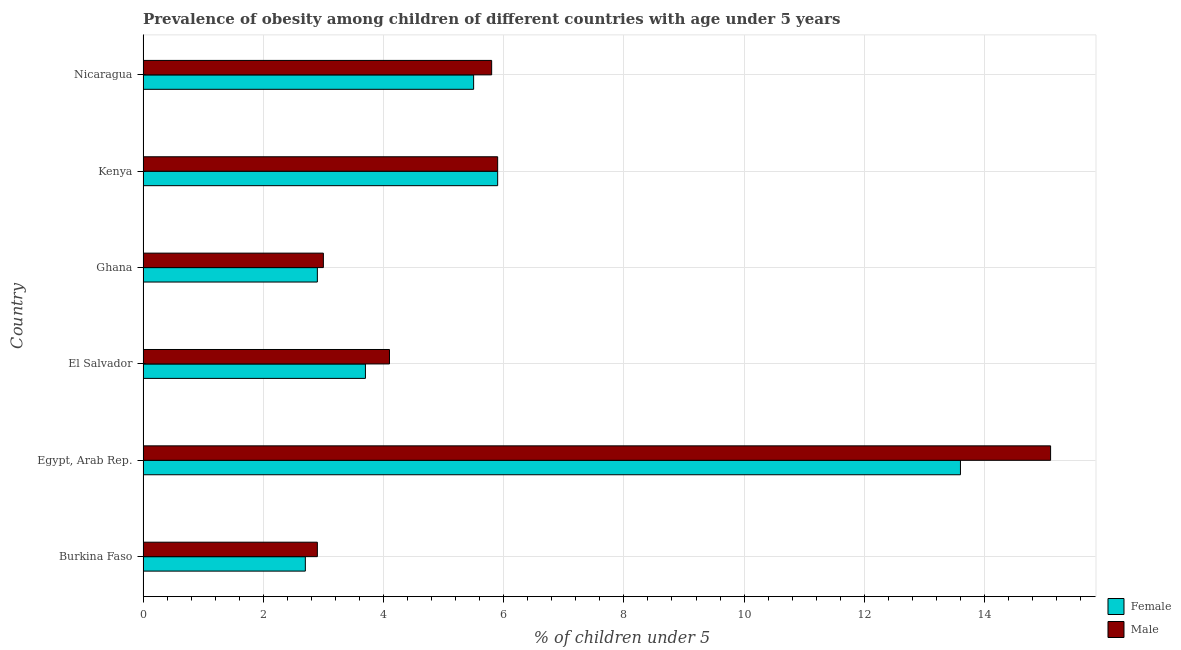How many groups of bars are there?
Your answer should be very brief. 6. Are the number of bars per tick equal to the number of legend labels?
Provide a short and direct response. Yes. Are the number of bars on each tick of the Y-axis equal?
Ensure brevity in your answer.  Yes. What is the label of the 2nd group of bars from the top?
Provide a succinct answer. Kenya. What is the percentage of obese male children in Kenya?
Offer a very short reply. 5.9. Across all countries, what is the maximum percentage of obese female children?
Give a very brief answer. 13.6. Across all countries, what is the minimum percentage of obese female children?
Give a very brief answer. 2.7. In which country was the percentage of obese female children maximum?
Provide a short and direct response. Egypt, Arab Rep. In which country was the percentage of obese male children minimum?
Offer a very short reply. Burkina Faso. What is the total percentage of obese male children in the graph?
Your response must be concise. 36.8. What is the difference between the percentage of obese male children in Burkina Faso and that in Egypt, Arab Rep.?
Your answer should be compact. -12.2. What is the difference between the percentage of obese male children in Burkina Faso and the percentage of obese female children in El Salvador?
Your response must be concise. -0.8. What is the average percentage of obese female children per country?
Offer a terse response. 5.72. In how many countries, is the percentage of obese male children greater than 1.2000000000000002 %?
Offer a terse response. 6. What is the ratio of the percentage of obese male children in El Salvador to that in Ghana?
Your response must be concise. 1.37. Is the difference between the percentage of obese female children in Egypt, Arab Rep. and Ghana greater than the difference between the percentage of obese male children in Egypt, Arab Rep. and Ghana?
Your answer should be compact. No. In how many countries, is the percentage of obese male children greater than the average percentage of obese male children taken over all countries?
Your answer should be compact. 1. Is the sum of the percentage of obese male children in Egypt, Arab Rep. and Nicaragua greater than the maximum percentage of obese female children across all countries?
Your response must be concise. Yes. How many bars are there?
Your response must be concise. 12. Are the values on the major ticks of X-axis written in scientific E-notation?
Your answer should be compact. No. Does the graph contain any zero values?
Make the answer very short. No. Does the graph contain grids?
Ensure brevity in your answer.  Yes. How many legend labels are there?
Make the answer very short. 2. What is the title of the graph?
Make the answer very short. Prevalence of obesity among children of different countries with age under 5 years. Does "Residents" appear as one of the legend labels in the graph?
Keep it short and to the point. No. What is the label or title of the X-axis?
Ensure brevity in your answer.   % of children under 5. What is the  % of children under 5 of Female in Burkina Faso?
Offer a very short reply. 2.7. What is the  % of children under 5 of Male in Burkina Faso?
Provide a succinct answer. 2.9. What is the  % of children under 5 of Female in Egypt, Arab Rep.?
Offer a very short reply. 13.6. What is the  % of children under 5 of Male in Egypt, Arab Rep.?
Provide a succinct answer. 15.1. What is the  % of children under 5 of Female in El Salvador?
Your answer should be very brief. 3.7. What is the  % of children under 5 in Male in El Salvador?
Your answer should be very brief. 4.1. What is the  % of children under 5 of Female in Ghana?
Your answer should be very brief. 2.9. What is the  % of children under 5 of Female in Kenya?
Make the answer very short. 5.9. What is the  % of children under 5 of Male in Kenya?
Provide a succinct answer. 5.9. What is the  % of children under 5 of Male in Nicaragua?
Offer a very short reply. 5.8. Across all countries, what is the maximum  % of children under 5 in Female?
Keep it short and to the point. 13.6. Across all countries, what is the maximum  % of children under 5 in Male?
Make the answer very short. 15.1. Across all countries, what is the minimum  % of children under 5 in Female?
Keep it short and to the point. 2.7. Across all countries, what is the minimum  % of children under 5 in Male?
Provide a succinct answer. 2.9. What is the total  % of children under 5 of Female in the graph?
Provide a succinct answer. 34.3. What is the total  % of children under 5 of Male in the graph?
Give a very brief answer. 36.8. What is the difference between the  % of children under 5 of Female in Burkina Faso and that in Egypt, Arab Rep.?
Offer a terse response. -10.9. What is the difference between the  % of children under 5 of Male in Burkina Faso and that in Egypt, Arab Rep.?
Ensure brevity in your answer.  -12.2. What is the difference between the  % of children under 5 of Male in Burkina Faso and that in Ghana?
Keep it short and to the point. -0.1. What is the difference between the  % of children under 5 in Female in Burkina Faso and that in Nicaragua?
Make the answer very short. -2.8. What is the difference between the  % of children under 5 of Male in Egypt, Arab Rep. and that in El Salvador?
Your response must be concise. 11. What is the difference between the  % of children under 5 in Female in Egypt, Arab Rep. and that in Ghana?
Keep it short and to the point. 10.7. What is the difference between the  % of children under 5 in Male in Egypt, Arab Rep. and that in Ghana?
Your response must be concise. 12.1. What is the difference between the  % of children under 5 in Female in Egypt, Arab Rep. and that in Kenya?
Ensure brevity in your answer.  7.7. What is the difference between the  % of children under 5 of Male in Egypt, Arab Rep. and that in Kenya?
Ensure brevity in your answer.  9.2. What is the difference between the  % of children under 5 in Female in El Salvador and that in Ghana?
Your response must be concise. 0.8. What is the difference between the  % of children under 5 of Male in El Salvador and that in Ghana?
Give a very brief answer. 1.1. What is the difference between the  % of children under 5 of Female in El Salvador and that in Kenya?
Your response must be concise. -2.2. What is the difference between the  % of children under 5 of Male in El Salvador and that in Kenya?
Keep it short and to the point. -1.8. What is the difference between the  % of children under 5 of Male in El Salvador and that in Nicaragua?
Your response must be concise. -1.7. What is the difference between the  % of children under 5 in Male in Ghana and that in Nicaragua?
Offer a terse response. -2.8. What is the difference between the  % of children under 5 of Female in Kenya and that in Nicaragua?
Ensure brevity in your answer.  0.4. What is the difference between the  % of children under 5 in Male in Kenya and that in Nicaragua?
Offer a very short reply. 0.1. What is the difference between the  % of children under 5 in Female in Burkina Faso and the  % of children under 5 in Male in El Salvador?
Your response must be concise. -1.4. What is the difference between the  % of children under 5 in Female in Egypt, Arab Rep. and the  % of children under 5 in Male in Kenya?
Your answer should be compact. 7.7. What is the difference between the  % of children under 5 in Female in Kenya and the  % of children under 5 in Male in Nicaragua?
Ensure brevity in your answer.  0.1. What is the average  % of children under 5 in Female per country?
Your answer should be compact. 5.72. What is the average  % of children under 5 of Male per country?
Offer a very short reply. 6.13. What is the difference between the  % of children under 5 in Female and  % of children under 5 in Male in Burkina Faso?
Make the answer very short. -0.2. What is the difference between the  % of children under 5 in Female and  % of children under 5 in Male in Egypt, Arab Rep.?
Offer a terse response. -1.5. What is the difference between the  % of children under 5 in Female and  % of children under 5 in Male in El Salvador?
Offer a very short reply. -0.4. What is the difference between the  % of children under 5 in Female and  % of children under 5 in Male in Ghana?
Keep it short and to the point. -0.1. What is the difference between the  % of children under 5 in Female and  % of children under 5 in Male in Nicaragua?
Keep it short and to the point. -0.3. What is the ratio of the  % of children under 5 of Female in Burkina Faso to that in Egypt, Arab Rep.?
Your answer should be very brief. 0.2. What is the ratio of the  % of children under 5 in Male in Burkina Faso to that in Egypt, Arab Rep.?
Your answer should be compact. 0.19. What is the ratio of the  % of children under 5 of Female in Burkina Faso to that in El Salvador?
Make the answer very short. 0.73. What is the ratio of the  % of children under 5 in Male in Burkina Faso to that in El Salvador?
Keep it short and to the point. 0.71. What is the ratio of the  % of children under 5 in Male in Burkina Faso to that in Ghana?
Offer a terse response. 0.97. What is the ratio of the  % of children under 5 in Female in Burkina Faso to that in Kenya?
Make the answer very short. 0.46. What is the ratio of the  % of children under 5 in Male in Burkina Faso to that in Kenya?
Provide a short and direct response. 0.49. What is the ratio of the  % of children under 5 of Female in Burkina Faso to that in Nicaragua?
Offer a very short reply. 0.49. What is the ratio of the  % of children under 5 of Female in Egypt, Arab Rep. to that in El Salvador?
Offer a terse response. 3.68. What is the ratio of the  % of children under 5 in Male in Egypt, Arab Rep. to that in El Salvador?
Offer a very short reply. 3.68. What is the ratio of the  % of children under 5 of Female in Egypt, Arab Rep. to that in Ghana?
Your answer should be compact. 4.69. What is the ratio of the  % of children under 5 of Male in Egypt, Arab Rep. to that in Ghana?
Offer a very short reply. 5.03. What is the ratio of the  % of children under 5 in Female in Egypt, Arab Rep. to that in Kenya?
Keep it short and to the point. 2.31. What is the ratio of the  % of children under 5 of Male in Egypt, Arab Rep. to that in Kenya?
Keep it short and to the point. 2.56. What is the ratio of the  % of children under 5 of Female in Egypt, Arab Rep. to that in Nicaragua?
Your response must be concise. 2.47. What is the ratio of the  % of children under 5 of Male in Egypt, Arab Rep. to that in Nicaragua?
Your response must be concise. 2.6. What is the ratio of the  % of children under 5 of Female in El Salvador to that in Ghana?
Ensure brevity in your answer.  1.28. What is the ratio of the  % of children under 5 in Male in El Salvador to that in Ghana?
Offer a terse response. 1.37. What is the ratio of the  % of children under 5 in Female in El Salvador to that in Kenya?
Provide a short and direct response. 0.63. What is the ratio of the  % of children under 5 of Male in El Salvador to that in Kenya?
Keep it short and to the point. 0.69. What is the ratio of the  % of children under 5 of Female in El Salvador to that in Nicaragua?
Your answer should be compact. 0.67. What is the ratio of the  % of children under 5 of Male in El Salvador to that in Nicaragua?
Make the answer very short. 0.71. What is the ratio of the  % of children under 5 of Female in Ghana to that in Kenya?
Your answer should be compact. 0.49. What is the ratio of the  % of children under 5 of Male in Ghana to that in Kenya?
Make the answer very short. 0.51. What is the ratio of the  % of children under 5 of Female in Ghana to that in Nicaragua?
Give a very brief answer. 0.53. What is the ratio of the  % of children under 5 of Male in Ghana to that in Nicaragua?
Make the answer very short. 0.52. What is the ratio of the  % of children under 5 of Female in Kenya to that in Nicaragua?
Your answer should be compact. 1.07. What is the ratio of the  % of children under 5 of Male in Kenya to that in Nicaragua?
Your answer should be very brief. 1.02. What is the difference between the highest and the second highest  % of children under 5 in Female?
Give a very brief answer. 7.7. What is the difference between the highest and the lowest  % of children under 5 in Female?
Make the answer very short. 10.9. 